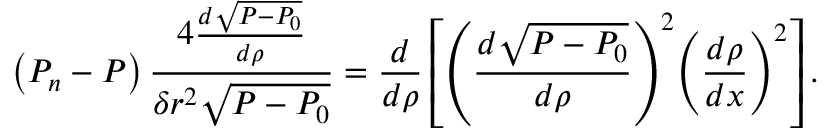<formula> <loc_0><loc_0><loc_500><loc_500>\left ( P _ { n } - P \right ) \frac { 4 \frac { d \sqrt { P - P _ { 0 } } } { d \rho } } { \delta r ^ { 2 } \sqrt { P - P _ { 0 } } } = \frac { d } { d \rho } \left [ { \left ( \frac { d \sqrt { P - P _ { 0 } } } { d \rho } \right ) } ^ { 2 } { \left ( \frac { d \rho } { d x } \right ) } ^ { 2 } \right ] .</formula> 